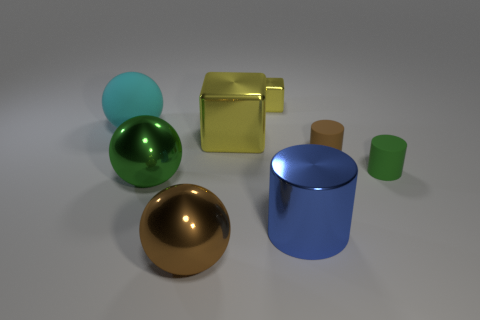What number of other things are the same color as the large shiny cube?
Your answer should be compact. 1. There is another cube that is the same color as the small cube; what is it made of?
Keep it short and to the point. Metal. What is the size of the shiny object that is the same color as the small metallic block?
Your response must be concise. Large. There is a brown object right of the brown object to the left of the blue metallic thing; how big is it?
Make the answer very short. Small. Is the number of yellow things to the right of the brown metal ball less than the number of small green rubber objects to the left of the big green shiny thing?
Your answer should be compact. No. There is a matte object on the left side of the tiny brown thing; does it have the same color as the metal object behind the large cyan matte ball?
Ensure brevity in your answer.  No. There is a large thing that is to the left of the big metal cube and behind the tiny brown object; what is its material?
Give a very brief answer. Rubber. Is there a tiny shiny thing?
Provide a succinct answer. Yes. The small green object that is made of the same material as the big cyan ball is what shape?
Your answer should be compact. Cylinder. Do the large blue object and the matte object that is on the left side of the large yellow block have the same shape?
Provide a short and direct response. No. 